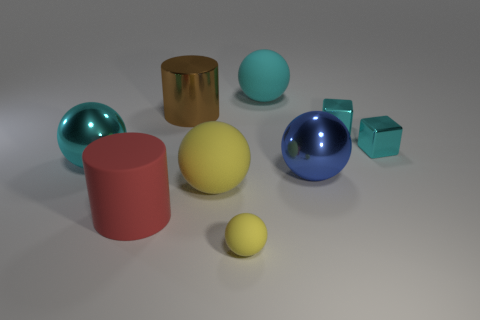How many things are either cyan rubber things or metal objects to the right of the big metal cylinder?
Make the answer very short. 4. Is the number of rubber things that are on the left side of the tiny yellow sphere greater than the number of rubber objects that are to the left of the large cyan rubber ball?
Ensure brevity in your answer.  No. The large thing that is on the right side of the rubber object that is behind the big metallic ball that is on the left side of the cyan matte ball is what shape?
Provide a short and direct response. Sphere. There is a large matte thing that is left of the large matte ball in front of the large cyan rubber ball; what shape is it?
Provide a succinct answer. Cylinder. Are there any small cyan cubes made of the same material as the small yellow object?
Provide a succinct answer. No. What number of green things are big matte blocks or matte things?
Your answer should be compact. 0. Is there a tiny metal ball of the same color as the large shiny cylinder?
Provide a short and direct response. No. What size is the cyan sphere that is made of the same material as the large red object?
Offer a terse response. Large. How many blocks are large matte objects or purple shiny things?
Ensure brevity in your answer.  0. Is the number of tiny metallic blocks greater than the number of large red things?
Your answer should be compact. Yes. 